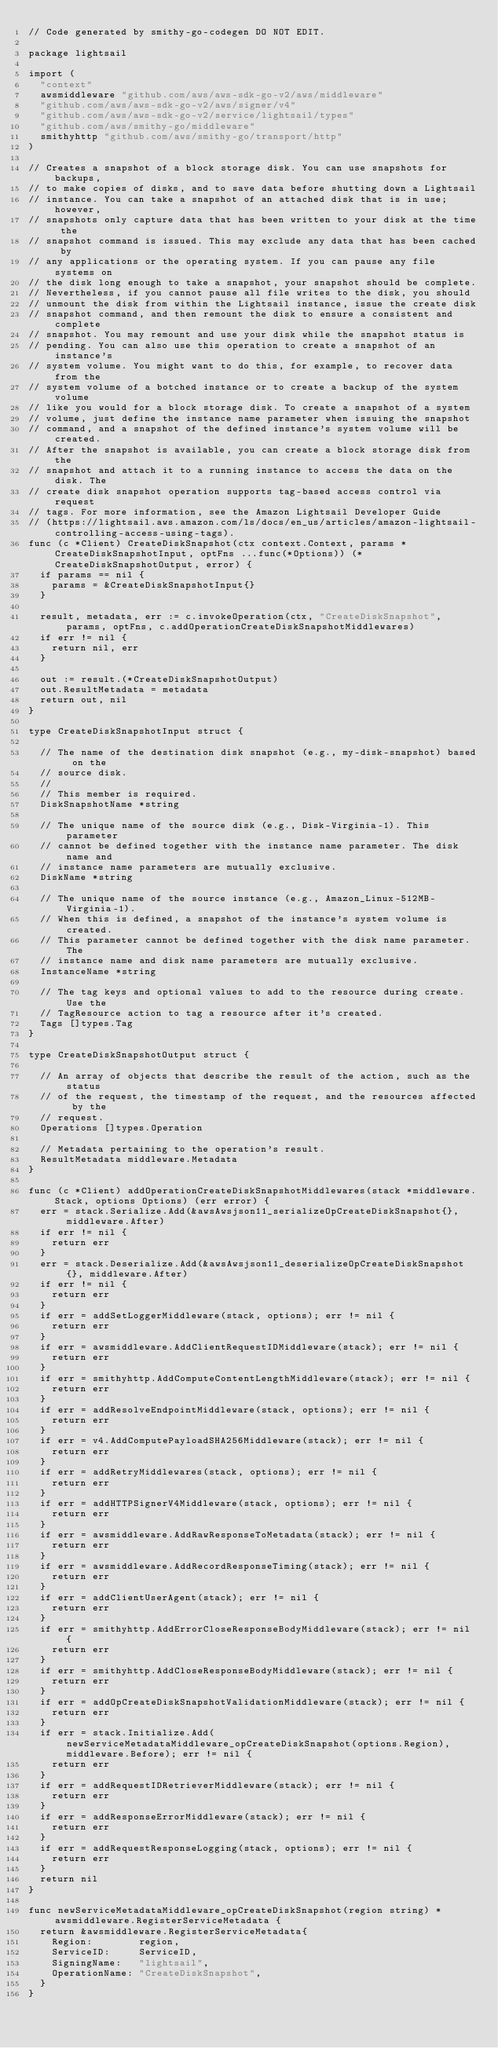<code> <loc_0><loc_0><loc_500><loc_500><_Go_>// Code generated by smithy-go-codegen DO NOT EDIT.

package lightsail

import (
	"context"
	awsmiddleware "github.com/aws/aws-sdk-go-v2/aws/middleware"
	"github.com/aws/aws-sdk-go-v2/aws/signer/v4"
	"github.com/aws/aws-sdk-go-v2/service/lightsail/types"
	"github.com/aws/smithy-go/middleware"
	smithyhttp "github.com/aws/smithy-go/transport/http"
)

// Creates a snapshot of a block storage disk. You can use snapshots for backups,
// to make copies of disks, and to save data before shutting down a Lightsail
// instance. You can take a snapshot of an attached disk that is in use; however,
// snapshots only capture data that has been written to your disk at the time the
// snapshot command is issued. This may exclude any data that has been cached by
// any applications or the operating system. If you can pause any file systems on
// the disk long enough to take a snapshot, your snapshot should be complete.
// Nevertheless, if you cannot pause all file writes to the disk, you should
// unmount the disk from within the Lightsail instance, issue the create disk
// snapshot command, and then remount the disk to ensure a consistent and complete
// snapshot. You may remount and use your disk while the snapshot status is
// pending. You can also use this operation to create a snapshot of an instance's
// system volume. You might want to do this, for example, to recover data from the
// system volume of a botched instance or to create a backup of the system volume
// like you would for a block storage disk. To create a snapshot of a system
// volume, just define the instance name parameter when issuing the snapshot
// command, and a snapshot of the defined instance's system volume will be created.
// After the snapshot is available, you can create a block storage disk from the
// snapshot and attach it to a running instance to access the data on the disk. The
// create disk snapshot operation supports tag-based access control via request
// tags. For more information, see the Amazon Lightsail Developer Guide
// (https://lightsail.aws.amazon.com/ls/docs/en_us/articles/amazon-lightsail-controlling-access-using-tags).
func (c *Client) CreateDiskSnapshot(ctx context.Context, params *CreateDiskSnapshotInput, optFns ...func(*Options)) (*CreateDiskSnapshotOutput, error) {
	if params == nil {
		params = &CreateDiskSnapshotInput{}
	}

	result, metadata, err := c.invokeOperation(ctx, "CreateDiskSnapshot", params, optFns, c.addOperationCreateDiskSnapshotMiddlewares)
	if err != nil {
		return nil, err
	}

	out := result.(*CreateDiskSnapshotOutput)
	out.ResultMetadata = metadata
	return out, nil
}

type CreateDiskSnapshotInput struct {

	// The name of the destination disk snapshot (e.g., my-disk-snapshot) based on the
	// source disk.
	//
	// This member is required.
	DiskSnapshotName *string

	// The unique name of the source disk (e.g., Disk-Virginia-1). This parameter
	// cannot be defined together with the instance name parameter. The disk name and
	// instance name parameters are mutually exclusive.
	DiskName *string

	// The unique name of the source instance (e.g., Amazon_Linux-512MB-Virginia-1).
	// When this is defined, a snapshot of the instance's system volume is created.
	// This parameter cannot be defined together with the disk name parameter. The
	// instance name and disk name parameters are mutually exclusive.
	InstanceName *string

	// The tag keys and optional values to add to the resource during create. Use the
	// TagResource action to tag a resource after it's created.
	Tags []types.Tag
}

type CreateDiskSnapshotOutput struct {

	// An array of objects that describe the result of the action, such as the status
	// of the request, the timestamp of the request, and the resources affected by the
	// request.
	Operations []types.Operation

	// Metadata pertaining to the operation's result.
	ResultMetadata middleware.Metadata
}

func (c *Client) addOperationCreateDiskSnapshotMiddlewares(stack *middleware.Stack, options Options) (err error) {
	err = stack.Serialize.Add(&awsAwsjson11_serializeOpCreateDiskSnapshot{}, middleware.After)
	if err != nil {
		return err
	}
	err = stack.Deserialize.Add(&awsAwsjson11_deserializeOpCreateDiskSnapshot{}, middleware.After)
	if err != nil {
		return err
	}
	if err = addSetLoggerMiddleware(stack, options); err != nil {
		return err
	}
	if err = awsmiddleware.AddClientRequestIDMiddleware(stack); err != nil {
		return err
	}
	if err = smithyhttp.AddComputeContentLengthMiddleware(stack); err != nil {
		return err
	}
	if err = addResolveEndpointMiddleware(stack, options); err != nil {
		return err
	}
	if err = v4.AddComputePayloadSHA256Middleware(stack); err != nil {
		return err
	}
	if err = addRetryMiddlewares(stack, options); err != nil {
		return err
	}
	if err = addHTTPSignerV4Middleware(stack, options); err != nil {
		return err
	}
	if err = awsmiddleware.AddRawResponseToMetadata(stack); err != nil {
		return err
	}
	if err = awsmiddleware.AddRecordResponseTiming(stack); err != nil {
		return err
	}
	if err = addClientUserAgent(stack); err != nil {
		return err
	}
	if err = smithyhttp.AddErrorCloseResponseBodyMiddleware(stack); err != nil {
		return err
	}
	if err = smithyhttp.AddCloseResponseBodyMiddleware(stack); err != nil {
		return err
	}
	if err = addOpCreateDiskSnapshotValidationMiddleware(stack); err != nil {
		return err
	}
	if err = stack.Initialize.Add(newServiceMetadataMiddleware_opCreateDiskSnapshot(options.Region), middleware.Before); err != nil {
		return err
	}
	if err = addRequestIDRetrieverMiddleware(stack); err != nil {
		return err
	}
	if err = addResponseErrorMiddleware(stack); err != nil {
		return err
	}
	if err = addRequestResponseLogging(stack, options); err != nil {
		return err
	}
	return nil
}

func newServiceMetadataMiddleware_opCreateDiskSnapshot(region string) *awsmiddleware.RegisterServiceMetadata {
	return &awsmiddleware.RegisterServiceMetadata{
		Region:        region,
		ServiceID:     ServiceID,
		SigningName:   "lightsail",
		OperationName: "CreateDiskSnapshot",
	}
}
</code> 